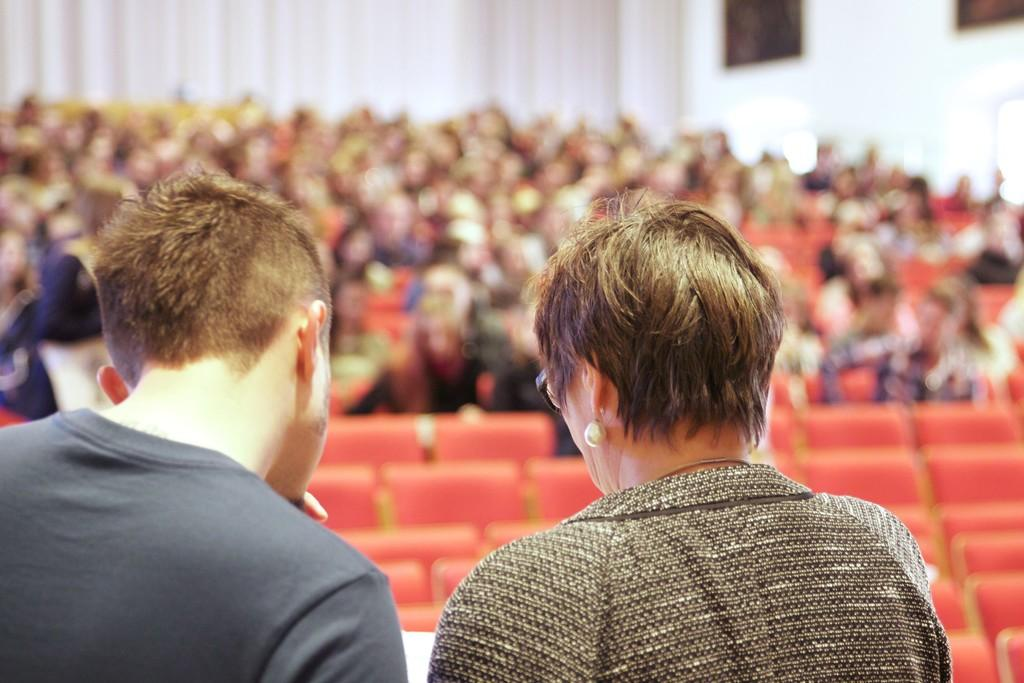How many people are visible in the image? There are two persons standing in the image. What can be seen in the background of the image? There are chairs in the background of the image. What are the people in the background doing? There are people sitting on the chairs in the background. What type of weather can be seen in the image? The provided facts do not mention any weather conditions, so it cannot be determined from the image. 